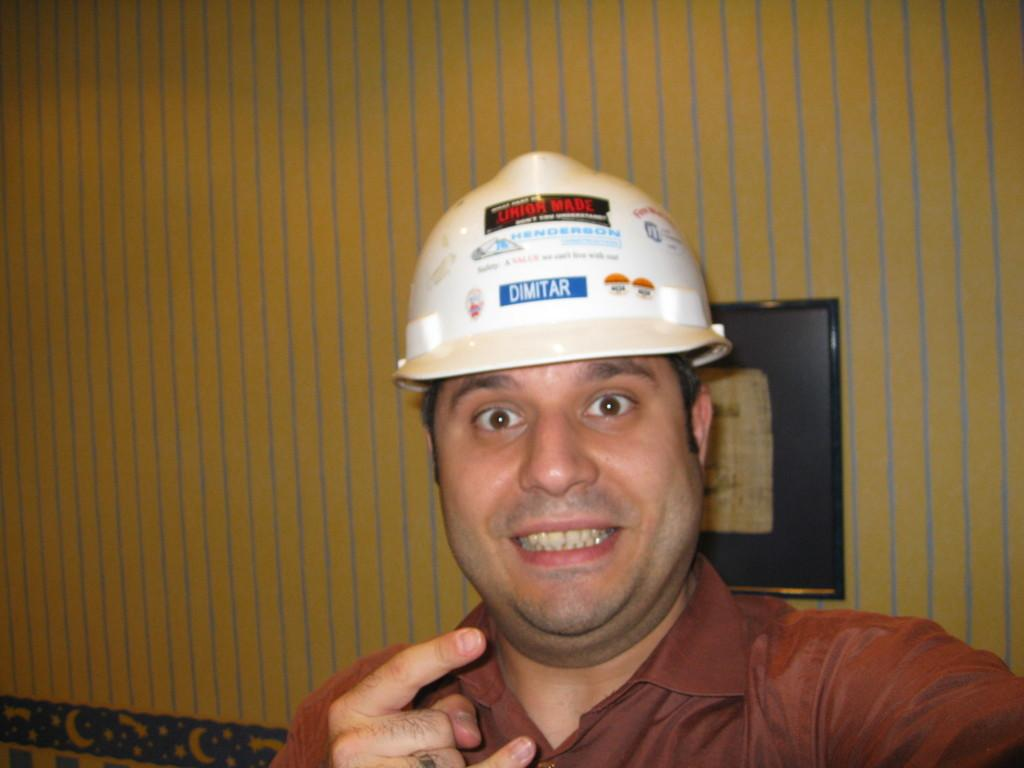Who is present in the image? There is a man in the image. What is the man doing in the image? The man is smiling in the image. What is the man wearing on his upper body? The man is wearing a brown shirt. What is the man wearing on his head? The man is wearing a white helmet. What color is the wall in the background? The wall in the background is yellow. What is attached to the wall? There is a black color frame attached to the wall. What type of skirt is the man wearing in the image? The man is not wearing a skirt in the image; he is wearing a brown shirt and a white helmet. 